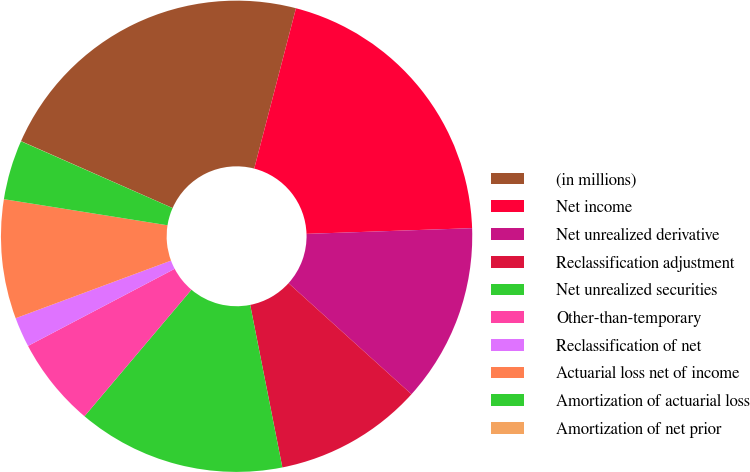Convert chart to OTSL. <chart><loc_0><loc_0><loc_500><loc_500><pie_chart><fcel>(in millions)<fcel>Net income<fcel>Net unrealized derivative<fcel>Reclassification adjustment<fcel>Net unrealized securities<fcel>Other-than-temporary<fcel>Reclassification of net<fcel>Actuarial loss net of income<fcel>Amortization of actuarial loss<fcel>Amortization of net prior<nl><fcel>22.44%<fcel>20.4%<fcel>12.24%<fcel>10.2%<fcel>14.28%<fcel>6.13%<fcel>2.05%<fcel>8.17%<fcel>4.09%<fcel>0.01%<nl></chart> 